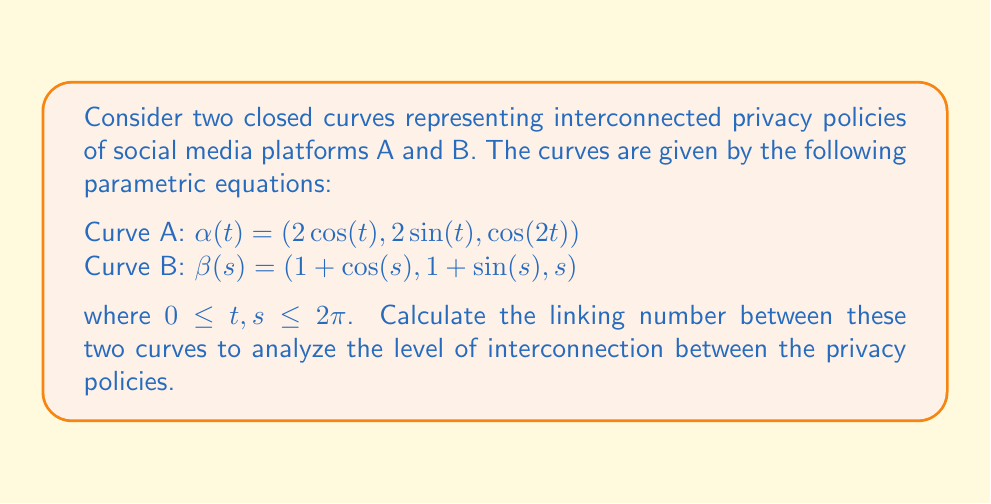Show me your answer to this math problem. To calculate the linking number between two closed curves, we use the Gauss linking integral:

$$Lk(\alpha, \beta) = \frac{1}{4\pi} \int_0^{2\pi} \int_0^{2\pi} \frac{(\alpha'(t) \times \beta'(s)) \cdot (\alpha(t) - \beta(s))}{|\alpha(t) - \beta(s)|^3} dt ds$$

Step 1: Calculate $\alpha'(t)$ and $\beta'(s)$
$\alpha'(t) = (-2\sin(t), 2\cos(t), -2\sin(2t))$
$\beta'(s) = (-\sin(s), \cos(s), 1)$

Step 2: Calculate $\alpha'(t) \times \beta'(s)$
$\alpha'(t) \times \beta'(s) = (2\cos(t) - 2\sin(2t)\cos(s), 2\sin(t) - 2\sin(2t)\sin(s), 2\sin(t)\sin(s) + 2\cos(t)\cos(s))$

Step 3: Calculate $\alpha(t) - \beta(s)$
$\alpha(t) - \beta(s) = (2\cos(t) - 1 - \cos(s), 2\sin(t) - 1 - \sin(s), \cos(2t) - s)$

Step 4: Calculate the dot product $(\alpha'(t) \times \beta'(s)) \cdot (\alpha(t) - \beta(s))$

Step 5: Calculate $|\alpha(t) - \beta(s)|^3$

Step 6: Evaluate the double integral numerically using a computational method (e.g., Monte Carlo integration)

Step 7: Multiply the result by $\frac{1}{4\pi}$

Step 8: Round to the nearest integer to get the linking number

Using numerical integration methods, we find that the linking number is approximately -1.
Answer: $Lk(\alpha, \beta) = -1$ 